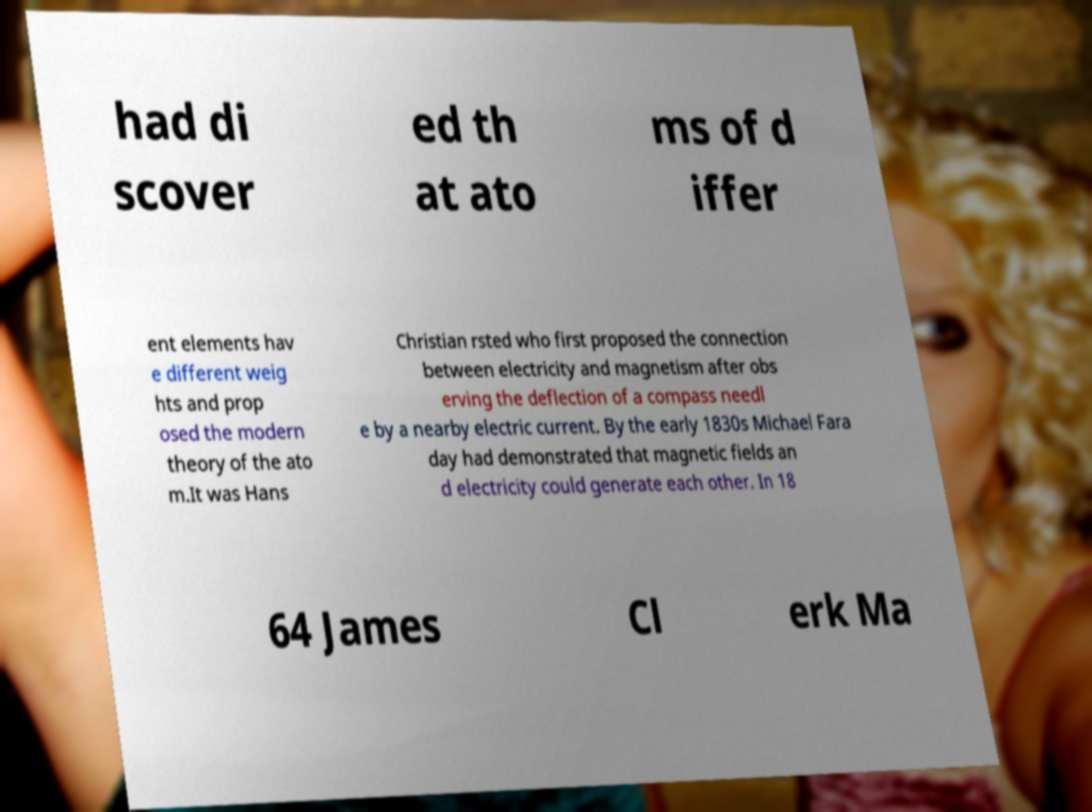Could you extract and type out the text from this image? had di scover ed th at ato ms of d iffer ent elements hav e different weig hts and prop osed the modern theory of the ato m.It was Hans Christian rsted who first proposed the connection between electricity and magnetism after obs erving the deflection of a compass needl e by a nearby electric current. By the early 1830s Michael Fara day had demonstrated that magnetic fields an d electricity could generate each other. In 18 64 James Cl erk Ma 